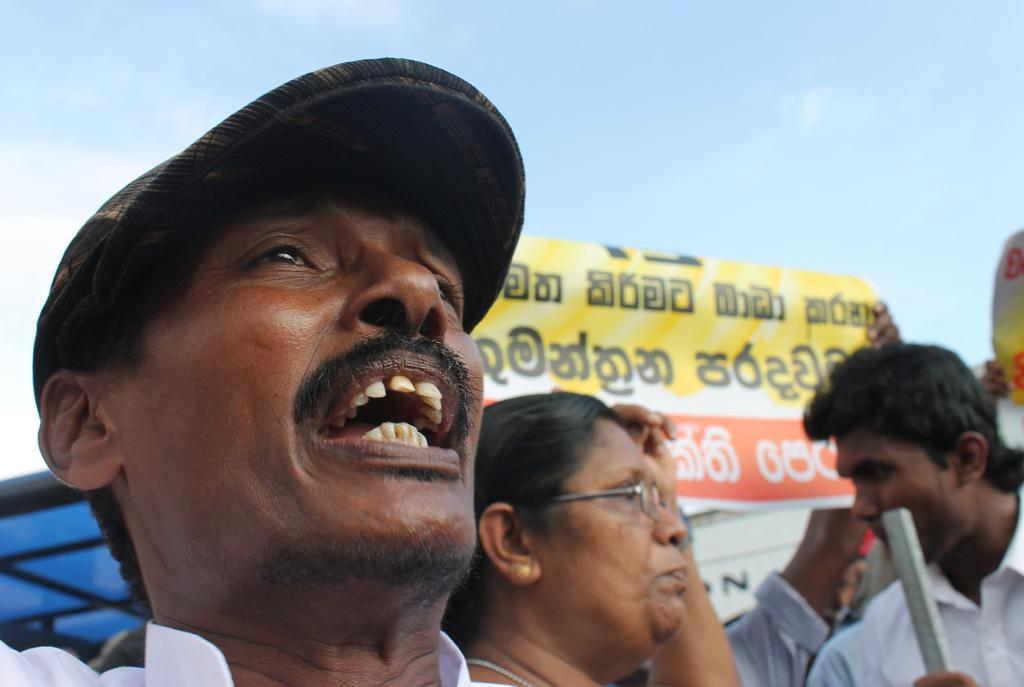What are the people in the image doing? The people in the image are standing and holding a banner. What colors can be seen on the banner? The banner has yellow, red, and white colors. What is the color of the sky in the image? The sky is blue and white in color. How much does the vest cost in the image? There is no vest present in the image, so it is not possible to determine its cost. 